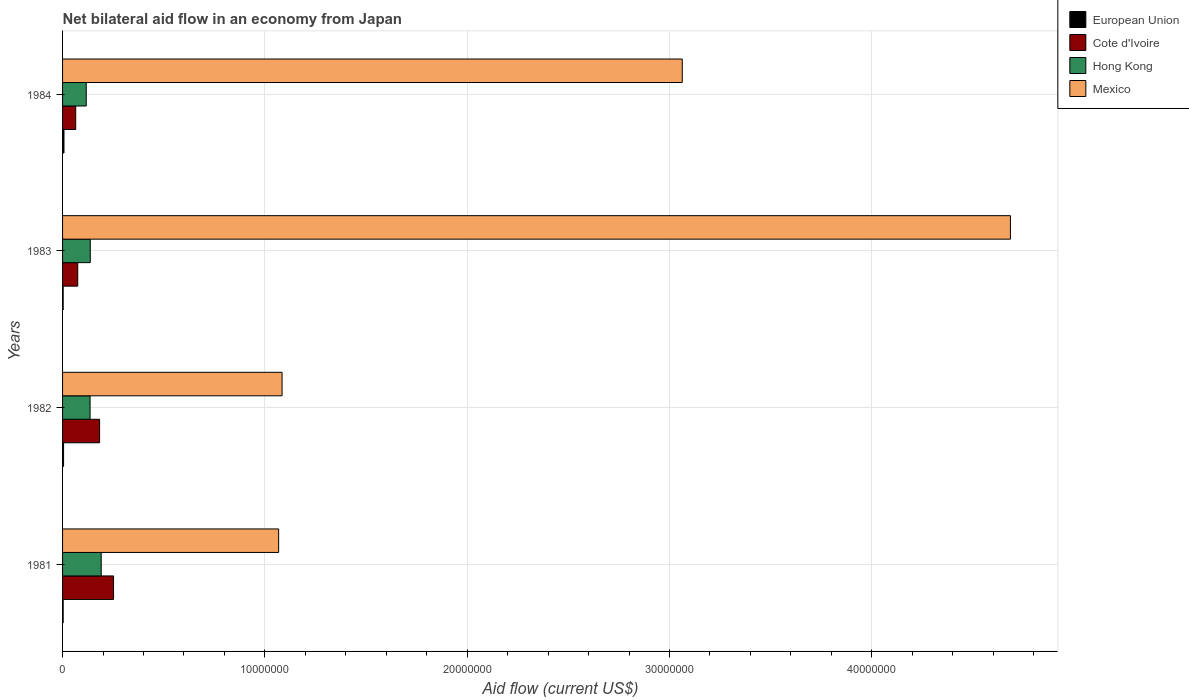How many groups of bars are there?
Keep it short and to the point. 4. Are the number of bars per tick equal to the number of legend labels?
Your response must be concise. Yes. Are the number of bars on each tick of the Y-axis equal?
Make the answer very short. Yes. How many bars are there on the 2nd tick from the bottom?
Offer a very short reply. 4. What is the net bilateral aid flow in Mexico in 1984?
Give a very brief answer. 3.06e+07. Across all years, what is the maximum net bilateral aid flow in Mexico?
Make the answer very short. 4.68e+07. Across all years, what is the minimum net bilateral aid flow in Cote d'Ivoire?
Provide a short and direct response. 6.50e+05. In which year was the net bilateral aid flow in Cote d'Ivoire maximum?
Offer a terse response. 1981. What is the total net bilateral aid flow in European Union in the graph?
Ensure brevity in your answer.  1.80e+05. What is the difference between the net bilateral aid flow in Mexico in 1981 and the net bilateral aid flow in Cote d'Ivoire in 1984?
Offer a very short reply. 1.00e+07. What is the average net bilateral aid flow in Mexico per year?
Your response must be concise. 2.48e+07. In the year 1983, what is the difference between the net bilateral aid flow in Hong Kong and net bilateral aid flow in Cote d'Ivoire?
Give a very brief answer. 6.20e+05. In how many years, is the net bilateral aid flow in Mexico greater than 34000000 US$?
Your answer should be very brief. 1. What is the ratio of the net bilateral aid flow in Cote d'Ivoire in 1982 to that in 1984?
Make the answer very short. 2.82. Is the net bilateral aid flow in Cote d'Ivoire in 1982 less than that in 1983?
Offer a terse response. No. What is the difference between the highest and the second highest net bilateral aid flow in Hong Kong?
Keep it short and to the point. 5.40e+05. What is the difference between the highest and the lowest net bilateral aid flow in Cote d'Ivoire?
Keep it short and to the point. 1.87e+06. In how many years, is the net bilateral aid flow in Hong Kong greater than the average net bilateral aid flow in Hong Kong taken over all years?
Ensure brevity in your answer.  1. Is it the case that in every year, the sum of the net bilateral aid flow in Mexico and net bilateral aid flow in Cote d'Ivoire is greater than the sum of net bilateral aid flow in Hong Kong and net bilateral aid flow in European Union?
Offer a terse response. Yes. What does the 3rd bar from the bottom in 1981 represents?
Your response must be concise. Hong Kong. Is it the case that in every year, the sum of the net bilateral aid flow in Hong Kong and net bilateral aid flow in European Union is greater than the net bilateral aid flow in Mexico?
Your answer should be compact. No. Are all the bars in the graph horizontal?
Keep it short and to the point. Yes. How many years are there in the graph?
Your response must be concise. 4. Does the graph contain any zero values?
Your answer should be compact. No. How many legend labels are there?
Your answer should be compact. 4. What is the title of the graph?
Provide a succinct answer. Net bilateral aid flow in an economy from Japan. What is the label or title of the X-axis?
Offer a very short reply. Aid flow (current US$). What is the label or title of the Y-axis?
Your answer should be very brief. Years. What is the Aid flow (current US$) of Cote d'Ivoire in 1981?
Your answer should be very brief. 2.52e+06. What is the Aid flow (current US$) of Hong Kong in 1981?
Keep it short and to the point. 1.91e+06. What is the Aid flow (current US$) of Mexico in 1981?
Provide a short and direct response. 1.07e+07. What is the Aid flow (current US$) of Cote d'Ivoire in 1982?
Provide a short and direct response. 1.83e+06. What is the Aid flow (current US$) of Hong Kong in 1982?
Give a very brief answer. 1.36e+06. What is the Aid flow (current US$) in Mexico in 1982?
Your answer should be compact. 1.08e+07. What is the Aid flow (current US$) of European Union in 1983?
Provide a short and direct response. 3.00e+04. What is the Aid flow (current US$) of Cote d'Ivoire in 1983?
Make the answer very short. 7.50e+05. What is the Aid flow (current US$) of Hong Kong in 1983?
Your response must be concise. 1.37e+06. What is the Aid flow (current US$) in Mexico in 1983?
Offer a terse response. 4.68e+07. What is the Aid flow (current US$) of European Union in 1984?
Ensure brevity in your answer.  7.00e+04. What is the Aid flow (current US$) in Cote d'Ivoire in 1984?
Offer a terse response. 6.50e+05. What is the Aid flow (current US$) of Hong Kong in 1984?
Your response must be concise. 1.17e+06. What is the Aid flow (current US$) in Mexico in 1984?
Make the answer very short. 3.06e+07. Across all years, what is the maximum Aid flow (current US$) in European Union?
Provide a short and direct response. 7.00e+04. Across all years, what is the maximum Aid flow (current US$) in Cote d'Ivoire?
Keep it short and to the point. 2.52e+06. Across all years, what is the maximum Aid flow (current US$) of Hong Kong?
Your answer should be very brief. 1.91e+06. Across all years, what is the maximum Aid flow (current US$) in Mexico?
Provide a succinct answer. 4.68e+07. Across all years, what is the minimum Aid flow (current US$) of Cote d'Ivoire?
Provide a succinct answer. 6.50e+05. Across all years, what is the minimum Aid flow (current US$) of Hong Kong?
Give a very brief answer. 1.17e+06. Across all years, what is the minimum Aid flow (current US$) in Mexico?
Provide a short and direct response. 1.07e+07. What is the total Aid flow (current US$) of Cote d'Ivoire in the graph?
Give a very brief answer. 5.75e+06. What is the total Aid flow (current US$) of Hong Kong in the graph?
Your answer should be compact. 5.81e+06. What is the total Aid flow (current US$) of Mexico in the graph?
Your answer should be compact. 9.90e+07. What is the difference between the Aid flow (current US$) of Cote d'Ivoire in 1981 and that in 1982?
Make the answer very short. 6.90e+05. What is the difference between the Aid flow (current US$) in Hong Kong in 1981 and that in 1982?
Provide a short and direct response. 5.50e+05. What is the difference between the Aid flow (current US$) in Cote d'Ivoire in 1981 and that in 1983?
Your response must be concise. 1.77e+06. What is the difference between the Aid flow (current US$) of Hong Kong in 1981 and that in 1983?
Provide a succinct answer. 5.40e+05. What is the difference between the Aid flow (current US$) of Mexico in 1981 and that in 1983?
Ensure brevity in your answer.  -3.62e+07. What is the difference between the Aid flow (current US$) in Cote d'Ivoire in 1981 and that in 1984?
Provide a succinct answer. 1.87e+06. What is the difference between the Aid flow (current US$) of Hong Kong in 1981 and that in 1984?
Keep it short and to the point. 7.40e+05. What is the difference between the Aid flow (current US$) of Mexico in 1981 and that in 1984?
Provide a short and direct response. -2.00e+07. What is the difference between the Aid flow (current US$) of European Union in 1982 and that in 1983?
Offer a very short reply. 2.00e+04. What is the difference between the Aid flow (current US$) of Cote d'Ivoire in 1982 and that in 1983?
Offer a terse response. 1.08e+06. What is the difference between the Aid flow (current US$) of Mexico in 1982 and that in 1983?
Offer a terse response. -3.60e+07. What is the difference between the Aid flow (current US$) of Cote d'Ivoire in 1982 and that in 1984?
Provide a short and direct response. 1.18e+06. What is the difference between the Aid flow (current US$) in Hong Kong in 1982 and that in 1984?
Provide a short and direct response. 1.90e+05. What is the difference between the Aid flow (current US$) of Mexico in 1982 and that in 1984?
Offer a terse response. -1.98e+07. What is the difference between the Aid flow (current US$) in European Union in 1983 and that in 1984?
Keep it short and to the point. -4.00e+04. What is the difference between the Aid flow (current US$) of Cote d'Ivoire in 1983 and that in 1984?
Offer a terse response. 1.00e+05. What is the difference between the Aid flow (current US$) in Mexico in 1983 and that in 1984?
Keep it short and to the point. 1.62e+07. What is the difference between the Aid flow (current US$) of European Union in 1981 and the Aid flow (current US$) of Cote d'Ivoire in 1982?
Ensure brevity in your answer.  -1.80e+06. What is the difference between the Aid flow (current US$) in European Union in 1981 and the Aid flow (current US$) in Hong Kong in 1982?
Ensure brevity in your answer.  -1.33e+06. What is the difference between the Aid flow (current US$) of European Union in 1981 and the Aid flow (current US$) of Mexico in 1982?
Provide a short and direct response. -1.08e+07. What is the difference between the Aid flow (current US$) of Cote d'Ivoire in 1981 and the Aid flow (current US$) of Hong Kong in 1982?
Give a very brief answer. 1.16e+06. What is the difference between the Aid flow (current US$) in Cote d'Ivoire in 1981 and the Aid flow (current US$) in Mexico in 1982?
Provide a short and direct response. -8.33e+06. What is the difference between the Aid flow (current US$) in Hong Kong in 1981 and the Aid flow (current US$) in Mexico in 1982?
Your answer should be very brief. -8.94e+06. What is the difference between the Aid flow (current US$) of European Union in 1981 and the Aid flow (current US$) of Cote d'Ivoire in 1983?
Your answer should be very brief. -7.20e+05. What is the difference between the Aid flow (current US$) of European Union in 1981 and the Aid flow (current US$) of Hong Kong in 1983?
Provide a short and direct response. -1.34e+06. What is the difference between the Aid flow (current US$) in European Union in 1981 and the Aid flow (current US$) in Mexico in 1983?
Provide a succinct answer. -4.68e+07. What is the difference between the Aid flow (current US$) of Cote d'Ivoire in 1981 and the Aid flow (current US$) of Hong Kong in 1983?
Ensure brevity in your answer.  1.15e+06. What is the difference between the Aid flow (current US$) in Cote d'Ivoire in 1981 and the Aid flow (current US$) in Mexico in 1983?
Offer a terse response. -4.43e+07. What is the difference between the Aid flow (current US$) of Hong Kong in 1981 and the Aid flow (current US$) of Mexico in 1983?
Offer a very short reply. -4.49e+07. What is the difference between the Aid flow (current US$) in European Union in 1981 and the Aid flow (current US$) in Cote d'Ivoire in 1984?
Provide a short and direct response. -6.20e+05. What is the difference between the Aid flow (current US$) of European Union in 1981 and the Aid flow (current US$) of Hong Kong in 1984?
Provide a succinct answer. -1.14e+06. What is the difference between the Aid flow (current US$) of European Union in 1981 and the Aid flow (current US$) of Mexico in 1984?
Offer a very short reply. -3.06e+07. What is the difference between the Aid flow (current US$) in Cote d'Ivoire in 1981 and the Aid flow (current US$) in Hong Kong in 1984?
Your answer should be very brief. 1.35e+06. What is the difference between the Aid flow (current US$) of Cote d'Ivoire in 1981 and the Aid flow (current US$) of Mexico in 1984?
Provide a succinct answer. -2.81e+07. What is the difference between the Aid flow (current US$) of Hong Kong in 1981 and the Aid flow (current US$) of Mexico in 1984?
Provide a short and direct response. -2.87e+07. What is the difference between the Aid flow (current US$) of European Union in 1982 and the Aid flow (current US$) of Cote d'Ivoire in 1983?
Offer a terse response. -7.00e+05. What is the difference between the Aid flow (current US$) of European Union in 1982 and the Aid flow (current US$) of Hong Kong in 1983?
Ensure brevity in your answer.  -1.32e+06. What is the difference between the Aid flow (current US$) of European Union in 1982 and the Aid flow (current US$) of Mexico in 1983?
Make the answer very short. -4.68e+07. What is the difference between the Aid flow (current US$) of Cote d'Ivoire in 1982 and the Aid flow (current US$) of Hong Kong in 1983?
Your answer should be compact. 4.60e+05. What is the difference between the Aid flow (current US$) in Cote d'Ivoire in 1982 and the Aid flow (current US$) in Mexico in 1983?
Give a very brief answer. -4.50e+07. What is the difference between the Aid flow (current US$) of Hong Kong in 1982 and the Aid flow (current US$) of Mexico in 1983?
Keep it short and to the point. -4.55e+07. What is the difference between the Aid flow (current US$) in European Union in 1982 and the Aid flow (current US$) in Cote d'Ivoire in 1984?
Provide a succinct answer. -6.00e+05. What is the difference between the Aid flow (current US$) of European Union in 1982 and the Aid flow (current US$) of Hong Kong in 1984?
Offer a very short reply. -1.12e+06. What is the difference between the Aid flow (current US$) of European Union in 1982 and the Aid flow (current US$) of Mexico in 1984?
Your response must be concise. -3.06e+07. What is the difference between the Aid flow (current US$) in Cote d'Ivoire in 1982 and the Aid flow (current US$) in Hong Kong in 1984?
Provide a succinct answer. 6.60e+05. What is the difference between the Aid flow (current US$) of Cote d'Ivoire in 1982 and the Aid flow (current US$) of Mexico in 1984?
Offer a terse response. -2.88e+07. What is the difference between the Aid flow (current US$) in Hong Kong in 1982 and the Aid flow (current US$) in Mexico in 1984?
Ensure brevity in your answer.  -2.93e+07. What is the difference between the Aid flow (current US$) in European Union in 1983 and the Aid flow (current US$) in Cote d'Ivoire in 1984?
Provide a succinct answer. -6.20e+05. What is the difference between the Aid flow (current US$) of European Union in 1983 and the Aid flow (current US$) of Hong Kong in 1984?
Offer a terse response. -1.14e+06. What is the difference between the Aid flow (current US$) of European Union in 1983 and the Aid flow (current US$) of Mexico in 1984?
Make the answer very short. -3.06e+07. What is the difference between the Aid flow (current US$) in Cote d'Ivoire in 1983 and the Aid flow (current US$) in Hong Kong in 1984?
Make the answer very short. -4.20e+05. What is the difference between the Aid flow (current US$) of Cote d'Ivoire in 1983 and the Aid flow (current US$) of Mexico in 1984?
Offer a terse response. -2.99e+07. What is the difference between the Aid flow (current US$) of Hong Kong in 1983 and the Aid flow (current US$) of Mexico in 1984?
Ensure brevity in your answer.  -2.93e+07. What is the average Aid flow (current US$) of European Union per year?
Your answer should be very brief. 4.50e+04. What is the average Aid flow (current US$) in Cote d'Ivoire per year?
Provide a succinct answer. 1.44e+06. What is the average Aid flow (current US$) of Hong Kong per year?
Your answer should be compact. 1.45e+06. What is the average Aid flow (current US$) of Mexico per year?
Your answer should be very brief. 2.48e+07. In the year 1981, what is the difference between the Aid flow (current US$) of European Union and Aid flow (current US$) of Cote d'Ivoire?
Offer a terse response. -2.49e+06. In the year 1981, what is the difference between the Aid flow (current US$) in European Union and Aid flow (current US$) in Hong Kong?
Your response must be concise. -1.88e+06. In the year 1981, what is the difference between the Aid flow (current US$) of European Union and Aid flow (current US$) of Mexico?
Your answer should be very brief. -1.06e+07. In the year 1981, what is the difference between the Aid flow (current US$) of Cote d'Ivoire and Aid flow (current US$) of Mexico?
Your response must be concise. -8.16e+06. In the year 1981, what is the difference between the Aid flow (current US$) of Hong Kong and Aid flow (current US$) of Mexico?
Your answer should be compact. -8.77e+06. In the year 1982, what is the difference between the Aid flow (current US$) of European Union and Aid flow (current US$) of Cote d'Ivoire?
Give a very brief answer. -1.78e+06. In the year 1982, what is the difference between the Aid flow (current US$) in European Union and Aid flow (current US$) in Hong Kong?
Make the answer very short. -1.31e+06. In the year 1982, what is the difference between the Aid flow (current US$) of European Union and Aid flow (current US$) of Mexico?
Your answer should be compact. -1.08e+07. In the year 1982, what is the difference between the Aid flow (current US$) in Cote d'Ivoire and Aid flow (current US$) in Hong Kong?
Your response must be concise. 4.70e+05. In the year 1982, what is the difference between the Aid flow (current US$) of Cote d'Ivoire and Aid flow (current US$) of Mexico?
Make the answer very short. -9.02e+06. In the year 1982, what is the difference between the Aid flow (current US$) of Hong Kong and Aid flow (current US$) of Mexico?
Your answer should be very brief. -9.49e+06. In the year 1983, what is the difference between the Aid flow (current US$) in European Union and Aid flow (current US$) in Cote d'Ivoire?
Make the answer very short. -7.20e+05. In the year 1983, what is the difference between the Aid flow (current US$) in European Union and Aid flow (current US$) in Hong Kong?
Provide a short and direct response. -1.34e+06. In the year 1983, what is the difference between the Aid flow (current US$) of European Union and Aid flow (current US$) of Mexico?
Your answer should be very brief. -4.68e+07. In the year 1983, what is the difference between the Aid flow (current US$) in Cote d'Ivoire and Aid flow (current US$) in Hong Kong?
Make the answer very short. -6.20e+05. In the year 1983, what is the difference between the Aid flow (current US$) in Cote d'Ivoire and Aid flow (current US$) in Mexico?
Your response must be concise. -4.61e+07. In the year 1983, what is the difference between the Aid flow (current US$) of Hong Kong and Aid flow (current US$) of Mexico?
Provide a succinct answer. -4.55e+07. In the year 1984, what is the difference between the Aid flow (current US$) in European Union and Aid flow (current US$) in Cote d'Ivoire?
Keep it short and to the point. -5.80e+05. In the year 1984, what is the difference between the Aid flow (current US$) in European Union and Aid flow (current US$) in Hong Kong?
Ensure brevity in your answer.  -1.10e+06. In the year 1984, what is the difference between the Aid flow (current US$) in European Union and Aid flow (current US$) in Mexico?
Offer a very short reply. -3.06e+07. In the year 1984, what is the difference between the Aid flow (current US$) in Cote d'Ivoire and Aid flow (current US$) in Hong Kong?
Offer a very short reply. -5.20e+05. In the year 1984, what is the difference between the Aid flow (current US$) in Cote d'Ivoire and Aid flow (current US$) in Mexico?
Your answer should be very brief. -3.00e+07. In the year 1984, what is the difference between the Aid flow (current US$) of Hong Kong and Aid flow (current US$) of Mexico?
Offer a terse response. -2.95e+07. What is the ratio of the Aid flow (current US$) in European Union in 1981 to that in 1982?
Make the answer very short. 0.6. What is the ratio of the Aid flow (current US$) of Cote d'Ivoire in 1981 to that in 1982?
Provide a short and direct response. 1.38. What is the ratio of the Aid flow (current US$) in Hong Kong in 1981 to that in 1982?
Provide a short and direct response. 1.4. What is the ratio of the Aid flow (current US$) in Mexico in 1981 to that in 1982?
Keep it short and to the point. 0.98. What is the ratio of the Aid flow (current US$) in European Union in 1981 to that in 1983?
Provide a short and direct response. 1. What is the ratio of the Aid flow (current US$) in Cote d'Ivoire in 1981 to that in 1983?
Provide a succinct answer. 3.36. What is the ratio of the Aid flow (current US$) in Hong Kong in 1981 to that in 1983?
Provide a succinct answer. 1.39. What is the ratio of the Aid flow (current US$) of Mexico in 1981 to that in 1983?
Your answer should be compact. 0.23. What is the ratio of the Aid flow (current US$) of European Union in 1981 to that in 1984?
Your response must be concise. 0.43. What is the ratio of the Aid flow (current US$) of Cote d'Ivoire in 1981 to that in 1984?
Ensure brevity in your answer.  3.88. What is the ratio of the Aid flow (current US$) of Hong Kong in 1981 to that in 1984?
Provide a short and direct response. 1.63. What is the ratio of the Aid flow (current US$) of Mexico in 1981 to that in 1984?
Provide a short and direct response. 0.35. What is the ratio of the Aid flow (current US$) of Cote d'Ivoire in 1982 to that in 1983?
Your response must be concise. 2.44. What is the ratio of the Aid flow (current US$) in Mexico in 1982 to that in 1983?
Give a very brief answer. 0.23. What is the ratio of the Aid flow (current US$) of Cote d'Ivoire in 1982 to that in 1984?
Provide a succinct answer. 2.82. What is the ratio of the Aid flow (current US$) in Hong Kong in 1982 to that in 1984?
Your response must be concise. 1.16. What is the ratio of the Aid flow (current US$) in Mexico in 1982 to that in 1984?
Keep it short and to the point. 0.35. What is the ratio of the Aid flow (current US$) in European Union in 1983 to that in 1984?
Your response must be concise. 0.43. What is the ratio of the Aid flow (current US$) in Cote d'Ivoire in 1983 to that in 1984?
Ensure brevity in your answer.  1.15. What is the ratio of the Aid flow (current US$) in Hong Kong in 1983 to that in 1984?
Provide a succinct answer. 1.17. What is the ratio of the Aid flow (current US$) in Mexico in 1983 to that in 1984?
Ensure brevity in your answer.  1.53. What is the difference between the highest and the second highest Aid flow (current US$) in European Union?
Provide a succinct answer. 2.00e+04. What is the difference between the highest and the second highest Aid flow (current US$) of Cote d'Ivoire?
Ensure brevity in your answer.  6.90e+05. What is the difference between the highest and the second highest Aid flow (current US$) of Hong Kong?
Provide a short and direct response. 5.40e+05. What is the difference between the highest and the second highest Aid flow (current US$) of Mexico?
Make the answer very short. 1.62e+07. What is the difference between the highest and the lowest Aid flow (current US$) in European Union?
Provide a short and direct response. 4.00e+04. What is the difference between the highest and the lowest Aid flow (current US$) of Cote d'Ivoire?
Your answer should be compact. 1.87e+06. What is the difference between the highest and the lowest Aid flow (current US$) in Hong Kong?
Your answer should be compact. 7.40e+05. What is the difference between the highest and the lowest Aid flow (current US$) in Mexico?
Ensure brevity in your answer.  3.62e+07. 